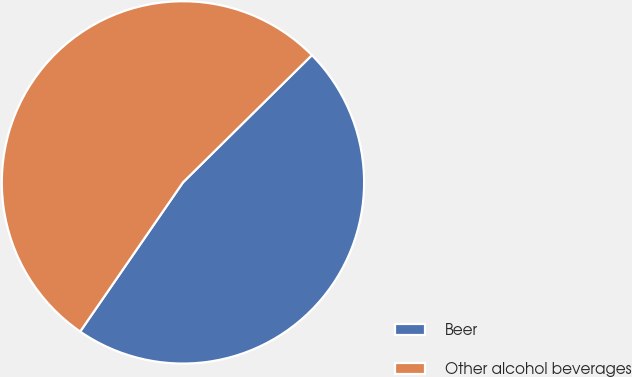Convert chart to OTSL. <chart><loc_0><loc_0><loc_500><loc_500><pie_chart><fcel>Beer<fcel>Other alcohol beverages<nl><fcel>47.0%<fcel>53.0%<nl></chart> 